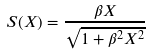Convert formula to latex. <formula><loc_0><loc_0><loc_500><loc_500>S ( X ) = \frac { \beta X } { \sqrt { 1 + \beta ^ { 2 } X ^ { 2 } } }</formula> 